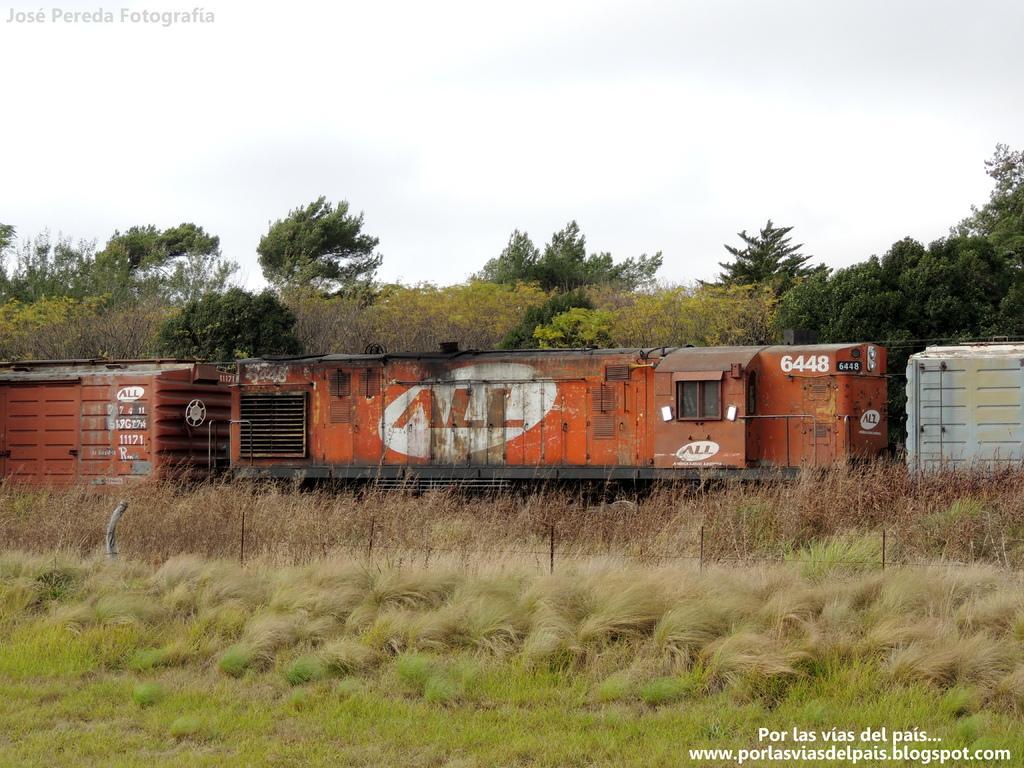Please provide a concise description of this image. In the picture I can see a train, fence, the grass and plants. In the background I can see trees and the sky. I can also see watermarks on the image. 